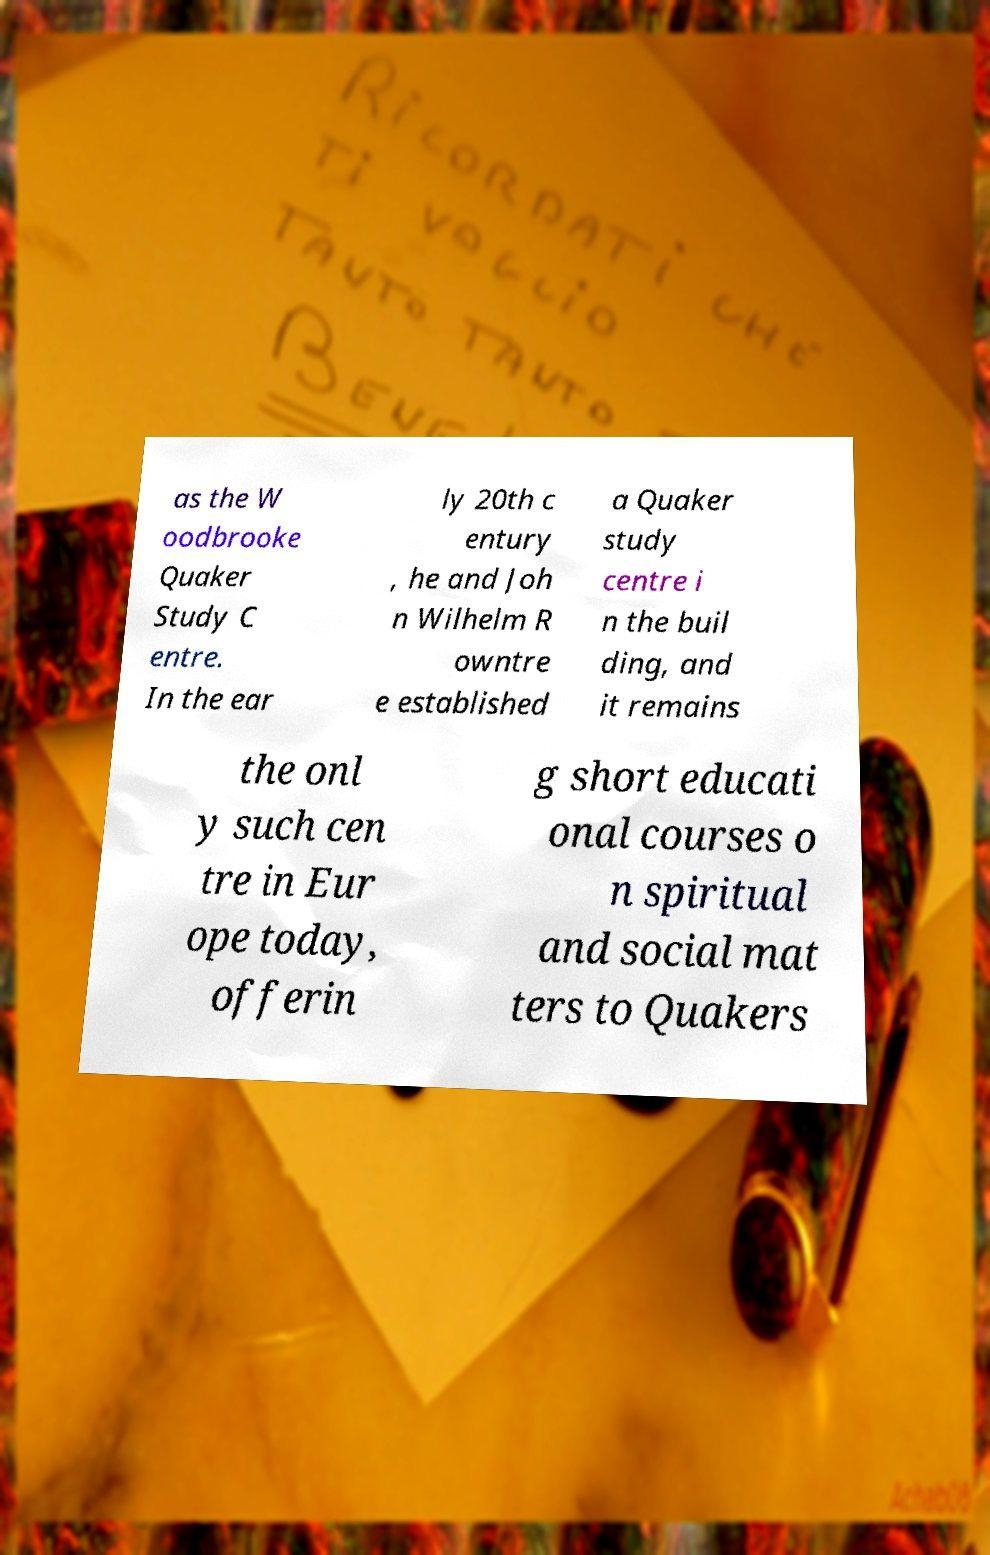Can you accurately transcribe the text from the provided image for me? as the W oodbrooke Quaker Study C entre. In the ear ly 20th c entury , he and Joh n Wilhelm R owntre e established a Quaker study centre i n the buil ding, and it remains the onl y such cen tre in Eur ope today, offerin g short educati onal courses o n spiritual and social mat ters to Quakers 